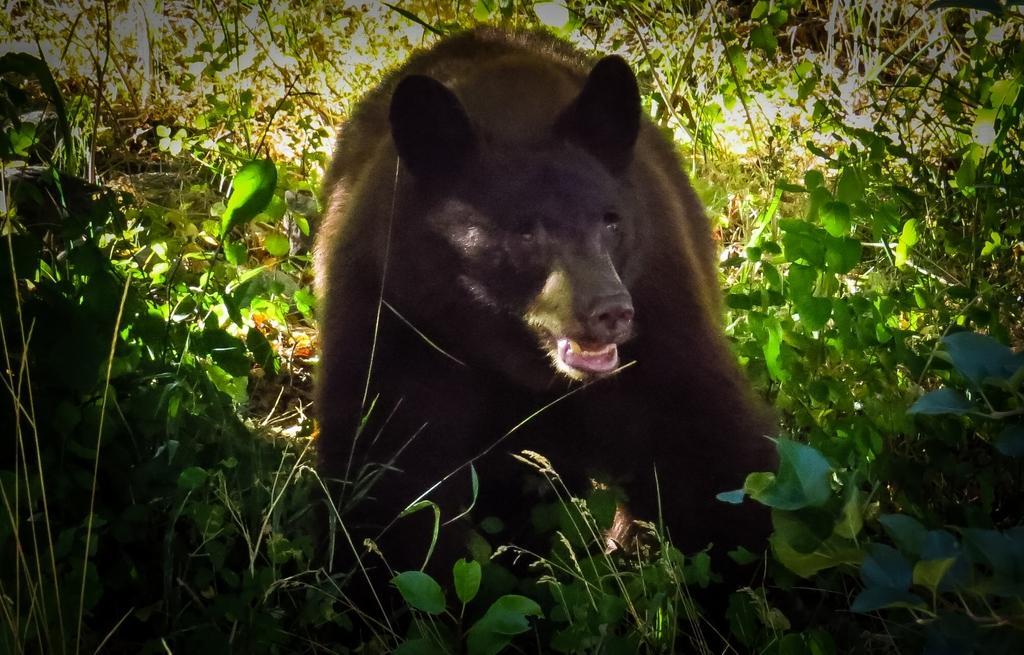Please provide a concise description of this image. In the middle of the picture, we see a bear. At the bottom, we see the shrubs. There are trees in the background. 